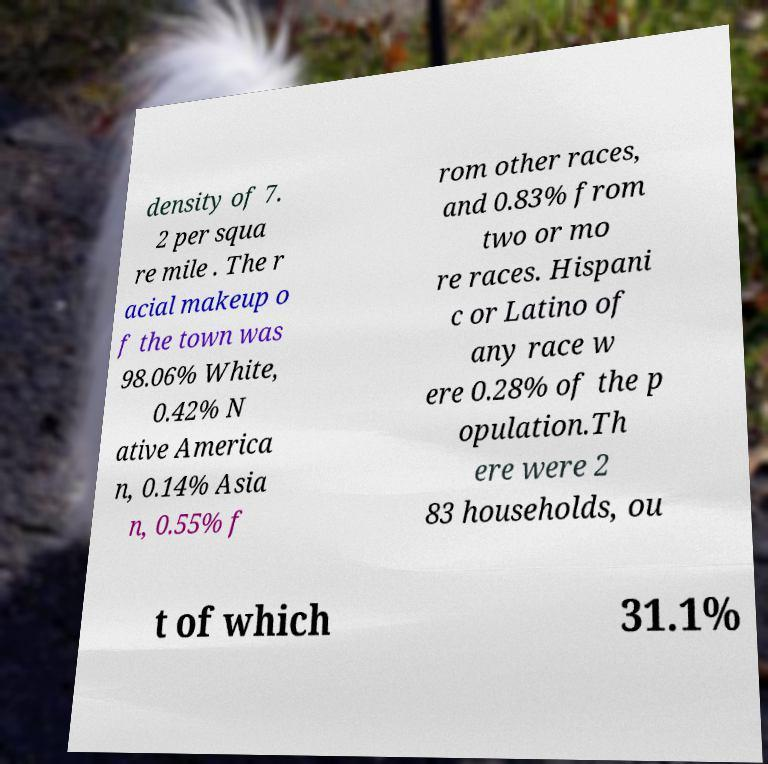For documentation purposes, I need the text within this image transcribed. Could you provide that? density of 7. 2 per squa re mile . The r acial makeup o f the town was 98.06% White, 0.42% N ative America n, 0.14% Asia n, 0.55% f rom other races, and 0.83% from two or mo re races. Hispani c or Latino of any race w ere 0.28% of the p opulation.Th ere were 2 83 households, ou t of which 31.1% 